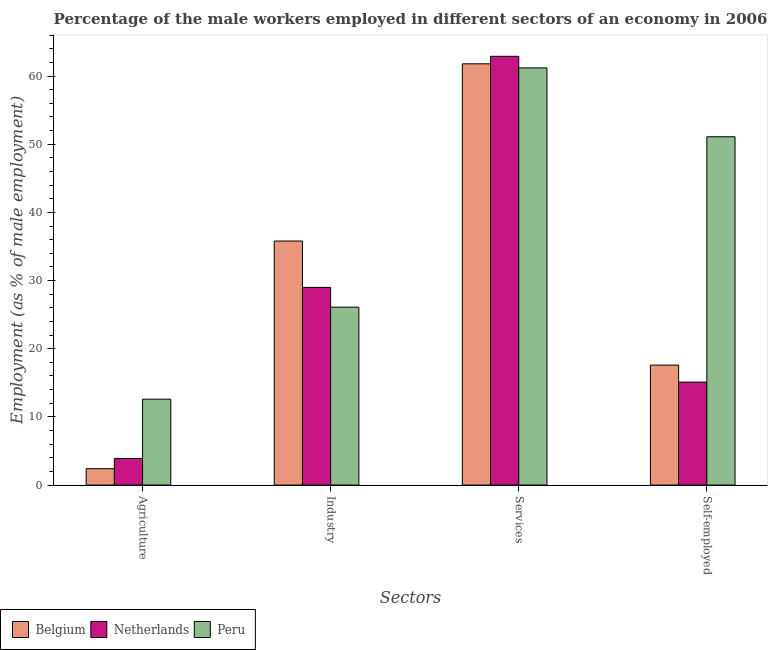How many different coloured bars are there?
Ensure brevity in your answer.  3. How many groups of bars are there?
Provide a short and direct response. 4. Are the number of bars per tick equal to the number of legend labels?
Your answer should be compact. Yes. What is the label of the 2nd group of bars from the left?
Offer a very short reply. Industry. What is the percentage of male workers in industry in Netherlands?
Make the answer very short. 29. Across all countries, what is the maximum percentage of self employed male workers?
Give a very brief answer. 51.1. Across all countries, what is the minimum percentage of male workers in services?
Offer a very short reply. 61.2. In which country was the percentage of self employed male workers maximum?
Keep it short and to the point. Peru. What is the total percentage of self employed male workers in the graph?
Keep it short and to the point. 83.8. What is the difference between the percentage of male workers in agriculture in Belgium and that in Peru?
Your answer should be compact. -10.2. What is the difference between the percentage of self employed male workers in Netherlands and the percentage of male workers in industry in Peru?
Provide a succinct answer. -11. What is the average percentage of male workers in industry per country?
Your response must be concise. 30.3. What is the difference between the percentage of self employed male workers and percentage of male workers in services in Peru?
Provide a short and direct response. -10.1. In how many countries, is the percentage of male workers in industry greater than 34 %?
Offer a terse response. 1. What is the ratio of the percentage of self employed male workers in Peru to that in Belgium?
Your response must be concise. 2.9. Is the percentage of male workers in agriculture in Netherlands less than that in Peru?
Give a very brief answer. Yes. Is the difference between the percentage of male workers in industry in Netherlands and Peru greater than the difference between the percentage of self employed male workers in Netherlands and Peru?
Your answer should be compact. Yes. What is the difference between the highest and the second highest percentage of male workers in agriculture?
Ensure brevity in your answer.  8.7. What is the difference between the highest and the lowest percentage of self employed male workers?
Provide a succinct answer. 36. In how many countries, is the percentage of male workers in agriculture greater than the average percentage of male workers in agriculture taken over all countries?
Ensure brevity in your answer.  1. Is the sum of the percentage of male workers in industry in Peru and Netherlands greater than the maximum percentage of male workers in agriculture across all countries?
Offer a very short reply. Yes. What does the 1st bar from the left in Services represents?
Provide a succinct answer. Belgium. Is it the case that in every country, the sum of the percentage of male workers in agriculture and percentage of male workers in industry is greater than the percentage of male workers in services?
Make the answer very short. No. Are all the bars in the graph horizontal?
Provide a short and direct response. No. Are the values on the major ticks of Y-axis written in scientific E-notation?
Your answer should be very brief. No. How many legend labels are there?
Offer a terse response. 3. What is the title of the graph?
Offer a terse response. Percentage of the male workers employed in different sectors of an economy in 2006. What is the label or title of the X-axis?
Provide a short and direct response. Sectors. What is the label or title of the Y-axis?
Your answer should be very brief. Employment (as % of male employment). What is the Employment (as % of male employment) in Belgium in Agriculture?
Your answer should be compact. 2.4. What is the Employment (as % of male employment) of Netherlands in Agriculture?
Make the answer very short. 3.9. What is the Employment (as % of male employment) of Peru in Agriculture?
Your answer should be compact. 12.6. What is the Employment (as % of male employment) in Belgium in Industry?
Your answer should be very brief. 35.8. What is the Employment (as % of male employment) of Netherlands in Industry?
Provide a short and direct response. 29. What is the Employment (as % of male employment) in Peru in Industry?
Your response must be concise. 26.1. What is the Employment (as % of male employment) in Belgium in Services?
Keep it short and to the point. 61.8. What is the Employment (as % of male employment) of Netherlands in Services?
Give a very brief answer. 62.9. What is the Employment (as % of male employment) of Peru in Services?
Offer a terse response. 61.2. What is the Employment (as % of male employment) in Belgium in Self-employed?
Offer a very short reply. 17.6. What is the Employment (as % of male employment) of Netherlands in Self-employed?
Keep it short and to the point. 15.1. What is the Employment (as % of male employment) in Peru in Self-employed?
Your response must be concise. 51.1. Across all Sectors, what is the maximum Employment (as % of male employment) in Belgium?
Your response must be concise. 61.8. Across all Sectors, what is the maximum Employment (as % of male employment) of Netherlands?
Your response must be concise. 62.9. Across all Sectors, what is the maximum Employment (as % of male employment) of Peru?
Your answer should be very brief. 61.2. Across all Sectors, what is the minimum Employment (as % of male employment) in Belgium?
Offer a terse response. 2.4. Across all Sectors, what is the minimum Employment (as % of male employment) in Netherlands?
Give a very brief answer. 3.9. Across all Sectors, what is the minimum Employment (as % of male employment) of Peru?
Provide a succinct answer. 12.6. What is the total Employment (as % of male employment) in Belgium in the graph?
Provide a short and direct response. 117.6. What is the total Employment (as % of male employment) in Netherlands in the graph?
Keep it short and to the point. 110.9. What is the total Employment (as % of male employment) of Peru in the graph?
Offer a terse response. 151. What is the difference between the Employment (as % of male employment) of Belgium in Agriculture and that in Industry?
Your answer should be very brief. -33.4. What is the difference between the Employment (as % of male employment) in Netherlands in Agriculture and that in Industry?
Offer a terse response. -25.1. What is the difference between the Employment (as % of male employment) of Peru in Agriculture and that in Industry?
Your answer should be very brief. -13.5. What is the difference between the Employment (as % of male employment) of Belgium in Agriculture and that in Services?
Give a very brief answer. -59.4. What is the difference between the Employment (as % of male employment) in Netherlands in Agriculture and that in Services?
Your answer should be very brief. -59. What is the difference between the Employment (as % of male employment) of Peru in Agriculture and that in Services?
Your response must be concise. -48.6. What is the difference between the Employment (as % of male employment) of Belgium in Agriculture and that in Self-employed?
Provide a short and direct response. -15.2. What is the difference between the Employment (as % of male employment) in Netherlands in Agriculture and that in Self-employed?
Provide a succinct answer. -11.2. What is the difference between the Employment (as % of male employment) of Peru in Agriculture and that in Self-employed?
Offer a very short reply. -38.5. What is the difference between the Employment (as % of male employment) in Belgium in Industry and that in Services?
Offer a terse response. -26. What is the difference between the Employment (as % of male employment) of Netherlands in Industry and that in Services?
Offer a very short reply. -33.9. What is the difference between the Employment (as % of male employment) of Peru in Industry and that in Services?
Offer a terse response. -35.1. What is the difference between the Employment (as % of male employment) of Belgium in Industry and that in Self-employed?
Keep it short and to the point. 18.2. What is the difference between the Employment (as % of male employment) of Peru in Industry and that in Self-employed?
Ensure brevity in your answer.  -25. What is the difference between the Employment (as % of male employment) in Belgium in Services and that in Self-employed?
Offer a terse response. 44.2. What is the difference between the Employment (as % of male employment) in Netherlands in Services and that in Self-employed?
Your answer should be very brief. 47.8. What is the difference between the Employment (as % of male employment) in Peru in Services and that in Self-employed?
Offer a terse response. 10.1. What is the difference between the Employment (as % of male employment) of Belgium in Agriculture and the Employment (as % of male employment) of Netherlands in Industry?
Keep it short and to the point. -26.6. What is the difference between the Employment (as % of male employment) of Belgium in Agriculture and the Employment (as % of male employment) of Peru in Industry?
Provide a short and direct response. -23.7. What is the difference between the Employment (as % of male employment) in Netherlands in Agriculture and the Employment (as % of male employment) in Peru in Industry?
Keep it short and to the point. -22.2. What is the difference between the Employment (as % of male employment) in Belgium in Agriculture and the Employment (as % of male employment) in Netherlands in Services?
Give a very brief answer. -60.5. What is the difference between the Employment (as % of male employment) in Belgium in Agriculture and the Employment (as % of male employment) in Peru in Services?
Make the answer very short. -58.8. What is the difference between the Employment (as % of male employment) in Netherlands in Agriculture and the Employment (as % of male employment) in Peru in Services?
Provide a succinct answer. -57.3. What is the difference between the Employment (as % of male employment) of Belgium in Agriculture and the Employment (as % of male employment) of Peru in Self-employed?
Make the answer very short. -48.7. What is the difference between the Employment (as % of male employment) in Netherlands in Agriculture and the Employment (as % of male employment) in Peru in Self-employed?
Your answer should be very brief. -47.2. What is the difference between the Employment (as % of male employment) of Belgium in Industry and the Employment (as % of male employment) of Netherlands in Services?
Your response must be concise. -27.1. What is the difference between the Employment (as % of male employment) in Belgium in Industry and the Employment (as % of male employment) in Peru in Services?
Provide a succinct answer. -25.4. What is the difference between the Employment (as % of male employment) in Netherlands in Industry and the Employment (as % of male employment) in Peru in Services?
Your answer should be compact. -32.2. What is the difference between the Employment (as % of male employment) in Belgium in Industry and the Employment (as % of male employment) in Netherlands in Self-employed?
Keep it short and to the point. 20.7. What is the difference between the Employment (as % of male employment) in Belgium in Industry and the Employment (as % of male employment) in Peru in Self-employed?
Give a very brief answer. -15.3. What is the difference between the Employment (as % of male employment) of Netherlands in Industry and the Employment (as % of male employment) of Peru in Self-employed?
Offer a very short reply. -22.1. What is the difference between the Employment (as % of male employment) of Belgium in Services and the Employment (as % of male employment) of Netherlands in Self-employed?
Provide a succinct answer. 46.7. What is the difference between the Employment (as % of male employment) in Belgium in Services and the Employment (as % of male employment) in Peru in Self-employed?
Offer a very short reply. 10.7. What is the average Employment (as % of male employment) of Belgium per Sectors?
Your answer should be compact. 29.4. What is the average Employment (as % of male employment) of Netherlands per Sectors?
Make the answer very short. 27.73. What is the average Employment (as % of male employment) of Peru per Sectors?
Your answer should be very brief. 37.75. What is the difference between the Employment (as % of male employment) of Belgium and Employment (as % of male employment) of Peru in Agriculture?
Provide a short and direct response. -10.2. What is the difference between the Employment (as % of male employment) of Netherlands and Employment (as % of male employment) of Peru in Agriculture?
Your answer should be compact. -8.7. What is the difference between the Employment (as % of male employment) of Belgium and Employment (as % of male employment) of Netherlands in Services?
Make the answer very short. -1.1. What is the difference between the Employment (as % of male employment) of Belgium and Employment (as % of male employment) of Peru in Services?
Provide a succinct answer. 0.6. What is the difference between the Employment (as % of male employment) in Netherlands and Employment (as % of male employment) in Peru in Services?
Your answer should be compact. 1.7. What is the difference between the Employment (as % of male employment) of Belgium and Employment (as % of male employment) of Netherlands in Self-employed?
Ensure brevity in your answer.  2.5. What is the difference between the Employment (as % of male employment) in Belgium and Employment (as % of male employment) in Peru in Self-employed?
Ensure brevity in your answer.  -33.5. What is the difference between the Employment (as % of male employment) in Netherlands and Employment (as % of male employment) in Peru in Self-employed?
Make the answer very short. -36. What is the ratio of the Employment (as % of male employment) in Belgium in Agriculture to that in Industry?
Your answer should be very brief. 0.07. What is the ratio of the Employment (as % of male employment) in Netherlands in Agriculture to that in Industry?
Ensure brevity in your answer.  0.13. What is the ratio of the Employment (as % of male employment) in Peru in Agriculture to that in Industry?
Your answer should be very brief. 0.48. What is the ratio of the Employment (as % of male employment) in Belgium in Agriculture to that in Services?
Give a very brief answer. 0.04. What is the ratio of the Employment (as % of male employment) in Netherlands in Agriculture to that in Services?
Ensure brevity in your answer.  0.06. What is the ratio of the Employment (as % of male employment) in Peru in Agriculture to that in Services?
Give a very brief answer. 0.21. What is the ratio of the Employment (as % of male employment) of Belgium in Agriculture to that in Self-employed?
Give a very brief answer. 0.14. What is the ratio of the Employment (as % of male employment) of Netherlands in Agriculture to that in Self-employed?
Ensure brevity in your answer.  0.26. What is the ratio of the Employment (as % of male employment) of Peru in Agriculture to that in Self-employed?
Offer a terse response. 0.25. What is the ratio of the Employment (as % of male employment) in Belgium in Industry to that in Services?
Offer a terse response. 0.58. What is the ratio of the Employment (as % of male employment) of Netherlands in Industry to that in Services?
Provide a succinct answer. 0.46. What is the ratio of the Employment (as % of male employment) in Peru in Industry to that in Services?
Give a very brief answer. 0.43. What is the ratio of the Employment (as % of male employment) of Belgium in Industry to that in Self-employed?
Provide a short and direct response. 2.03. What is the ratio of the Employment (as % of male employment) of Netherlands in Industry to that in Self-employed?
Make the answer very short. 1.92. What is the ratio of the Employment (as % of male employment) of Peru in Industry to that in Self-employed?
Keep it short and to the point. 0.51. What is the ratio of the Employment (as % of male employment) of Belgium in Services to that in Self-employed?
Your response must be concise. 3.51. What is the ratio of the Employment (as % of male employment) in Netherlands in Services to that in Self-employed?
Offer a terse response. 4.17. What is the ratio of the Employment (as % of male employment) in Peru in Services to that in Self-employed?
Your answer should be very brief. 1.2. What is the difference between the highest and the second highest Employment (as % of male employment) in Netherlands?
Provide a succinct answer. 33.9. What is the difference between the highest and the second highest Employment (as % of male employment) of Peru?
Provide a short and direct response. 10.1. What is the difference between the highest and the lowest Employment (as % of male employment) of Belgium?
Make the answer very short. 59.4. What is the difference between the highest and the lowest Employment (as % of male employment) in Netherlands?
Provide a succinct answer. 59. What is the difference between the highest and the lowest Employment (as % of male employment) of Peru?
Your answer should be compact. 48.6. 